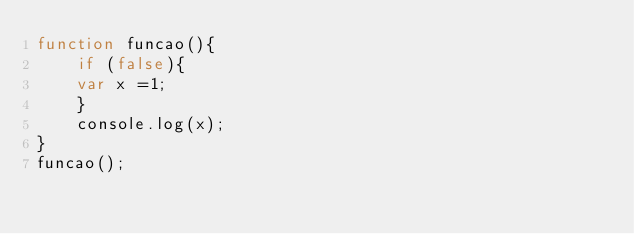<code> <loc_0><loc_0><loc_500><loc_500><_TypeScript_>function funcao(){
    if (false){
    var x =1;
    }
    console.log(x);
}
funcao();
</code> 